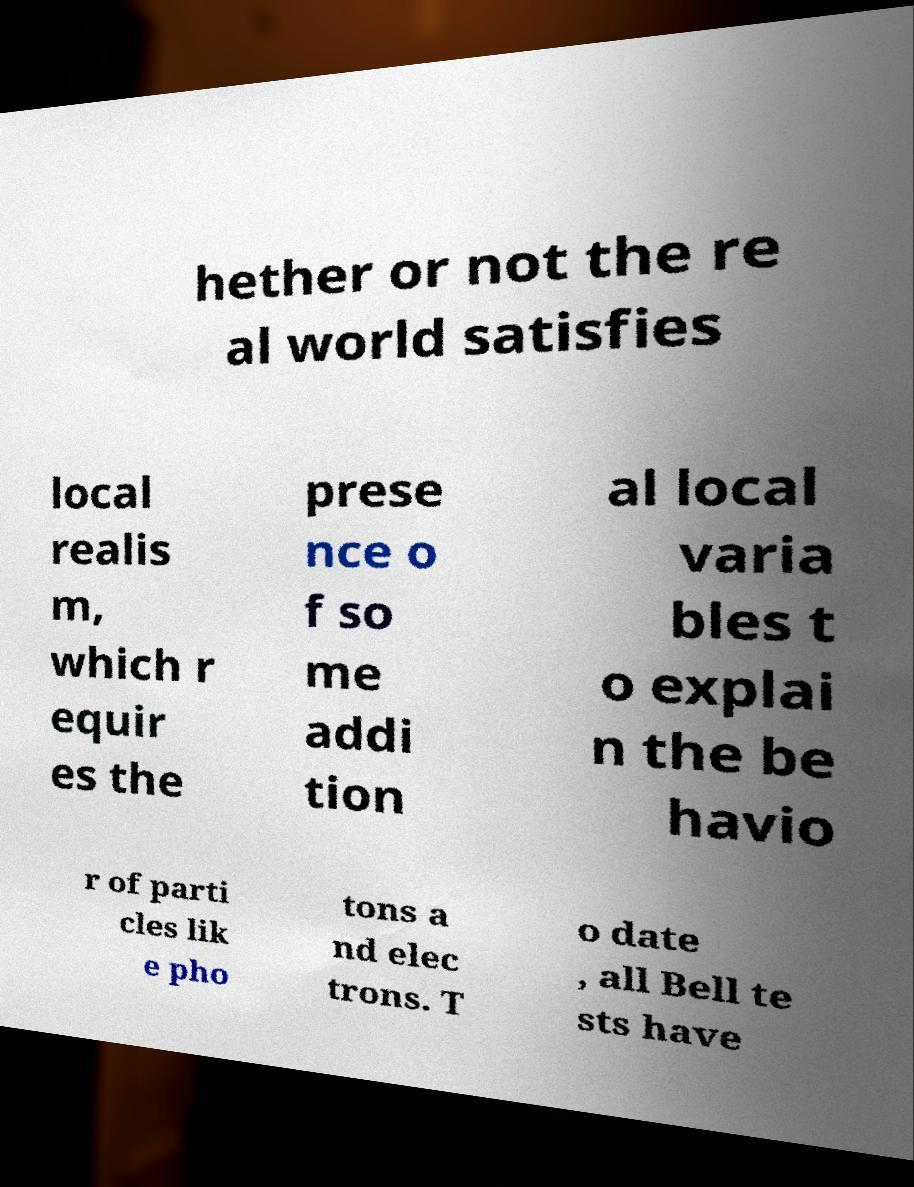There's text embedded in this image that I need extracted. Can you transcribe it verbatim? hether or not the re al world satisfies local realis m, which r equir es the prese nce o f so me addi tion al local varia bles t o explai n the be havio r of parti cles lik e pho tons a nd elec trons. T o date , all Bell te sts have 